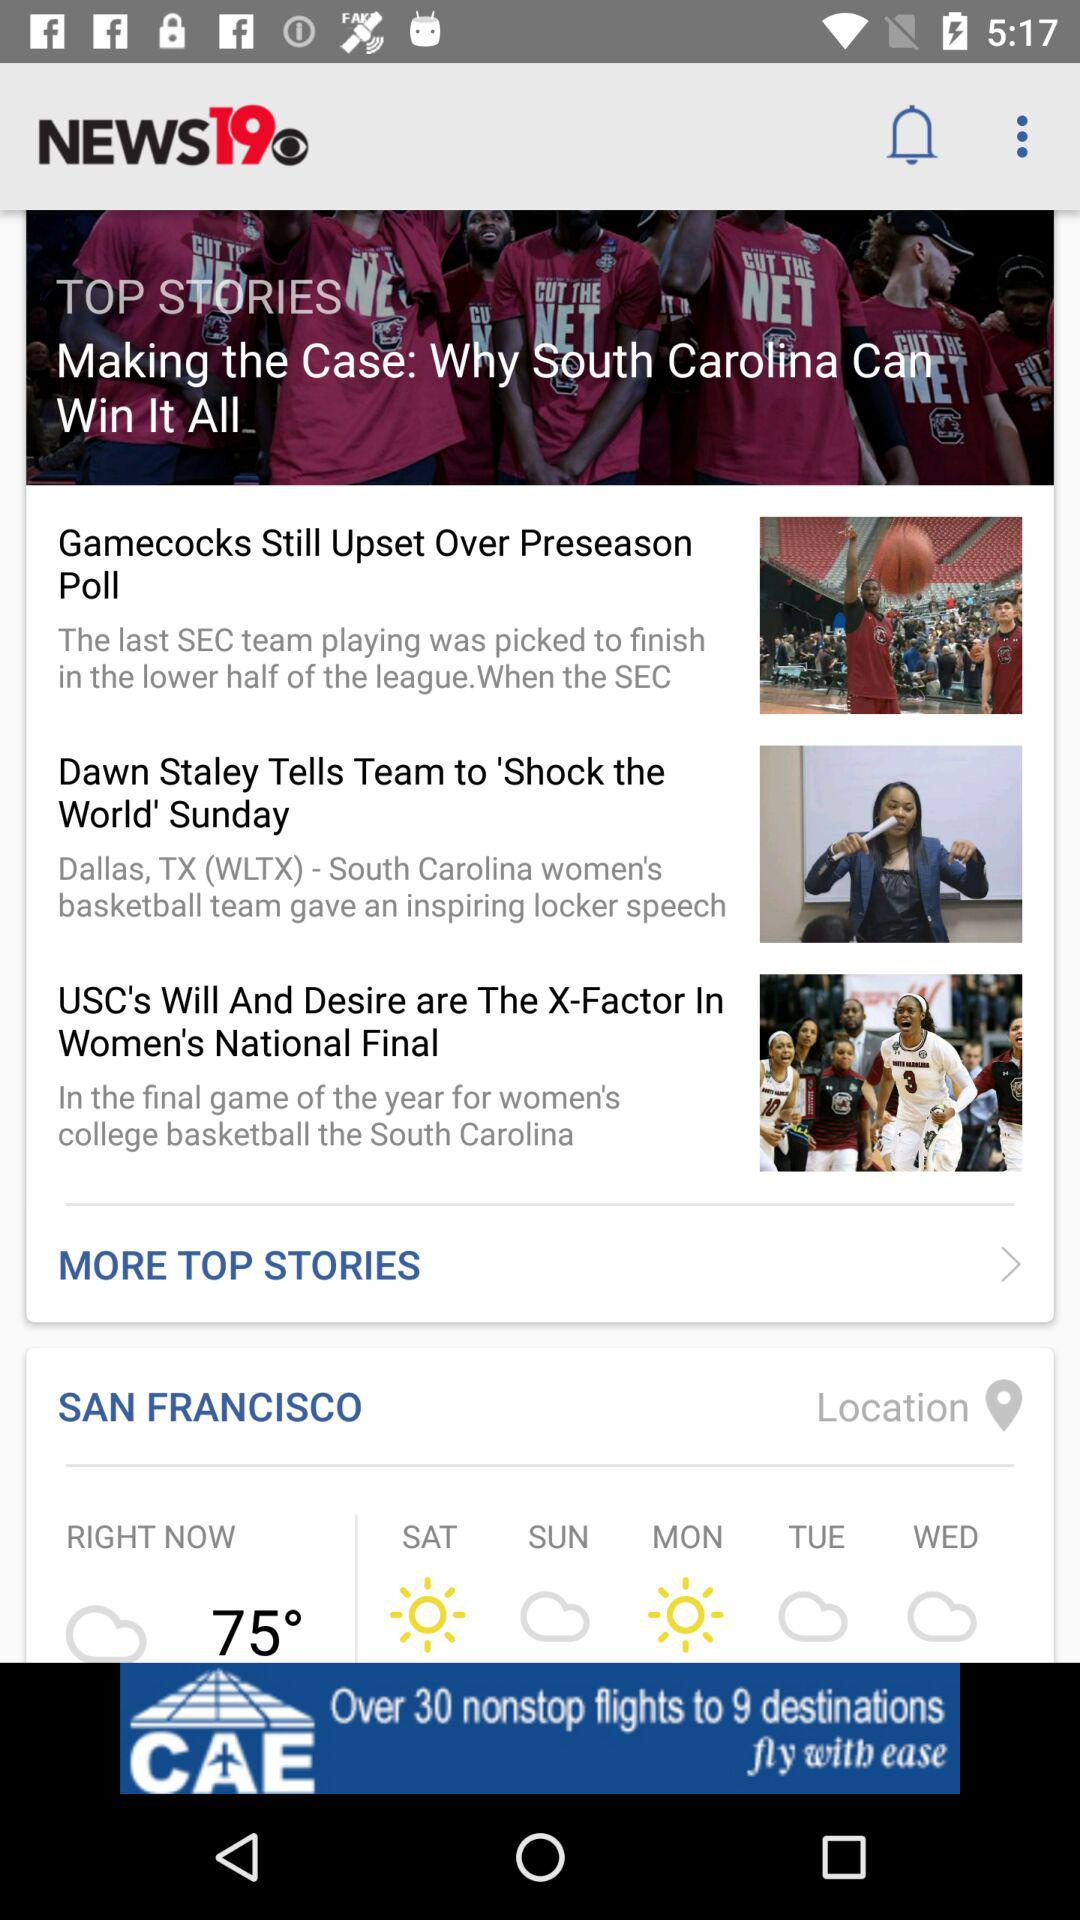What is the temperature? The temperature is 75°. 